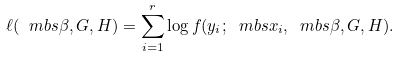Convert formula to latex. <formula><loc_0><loc_0><loc_500><loc_500>\ell ( \ m b s { \beta } , G , H ) = \sum _ { i = 1 } ^ { r } \log f ( y _ { i } ; \ m b s { x } _ { i } , \ m b s { \beta } , G , H ) .</formula> 